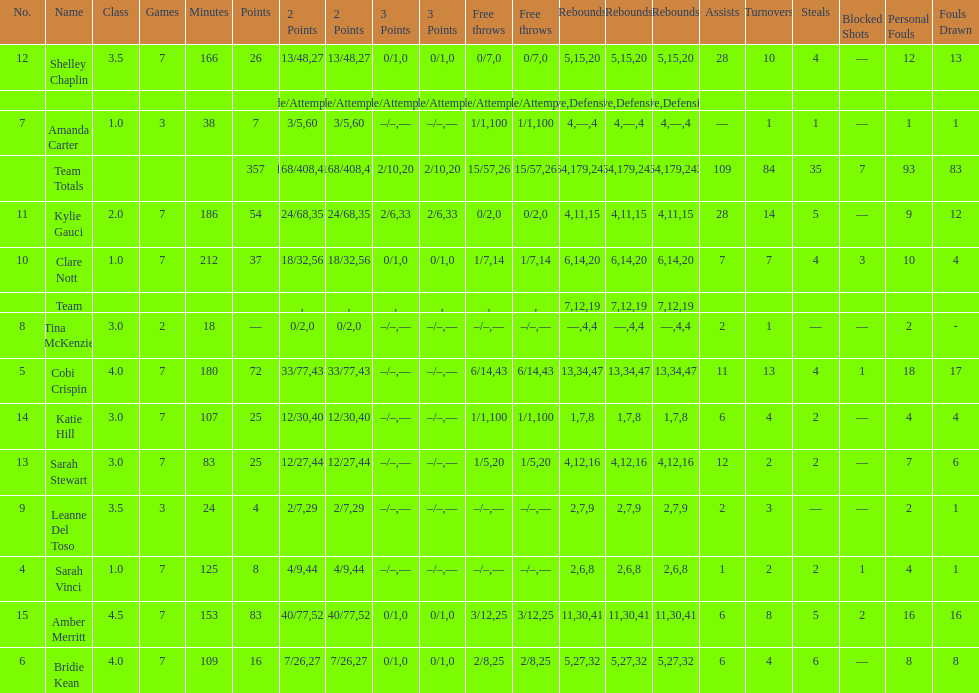Total of three-point shots attempted 10. 